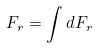Convert formula to latex. <formula><loc_0><loc_0><loc_500><loc_500>F _ { r } = \int d F _ { r }</formula> 